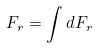Convert formula to latex. <formula><loc_0><loc_0><loc_500><loc_500>F _ { r } = \int d F _ { r }</formula> 